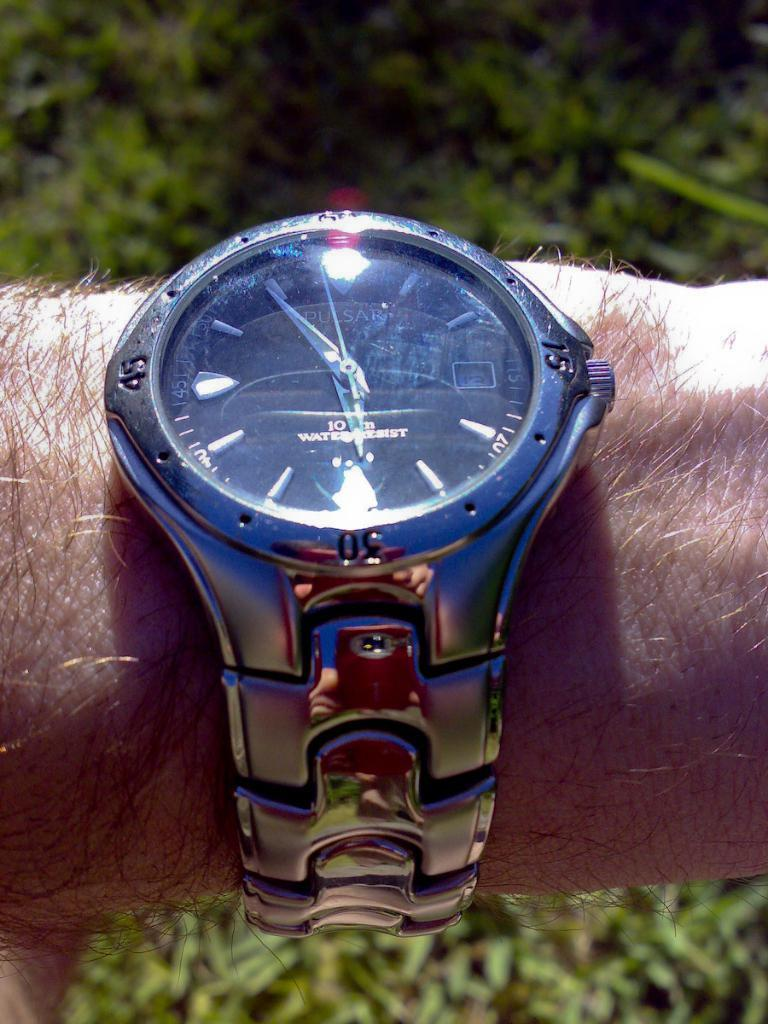What object is visible on someone's hand in the image? There is a watch on someone's hand in the image. What is the primary function of the object on the hand? The primary function of the watch is to tell time. What can be seen in the background of the image? There are leaves in the background of the image. What type of tramp can be seen jumping in the image? There is no tramp present in the image; it only features a watch on someone's hand and leaves in the background. 